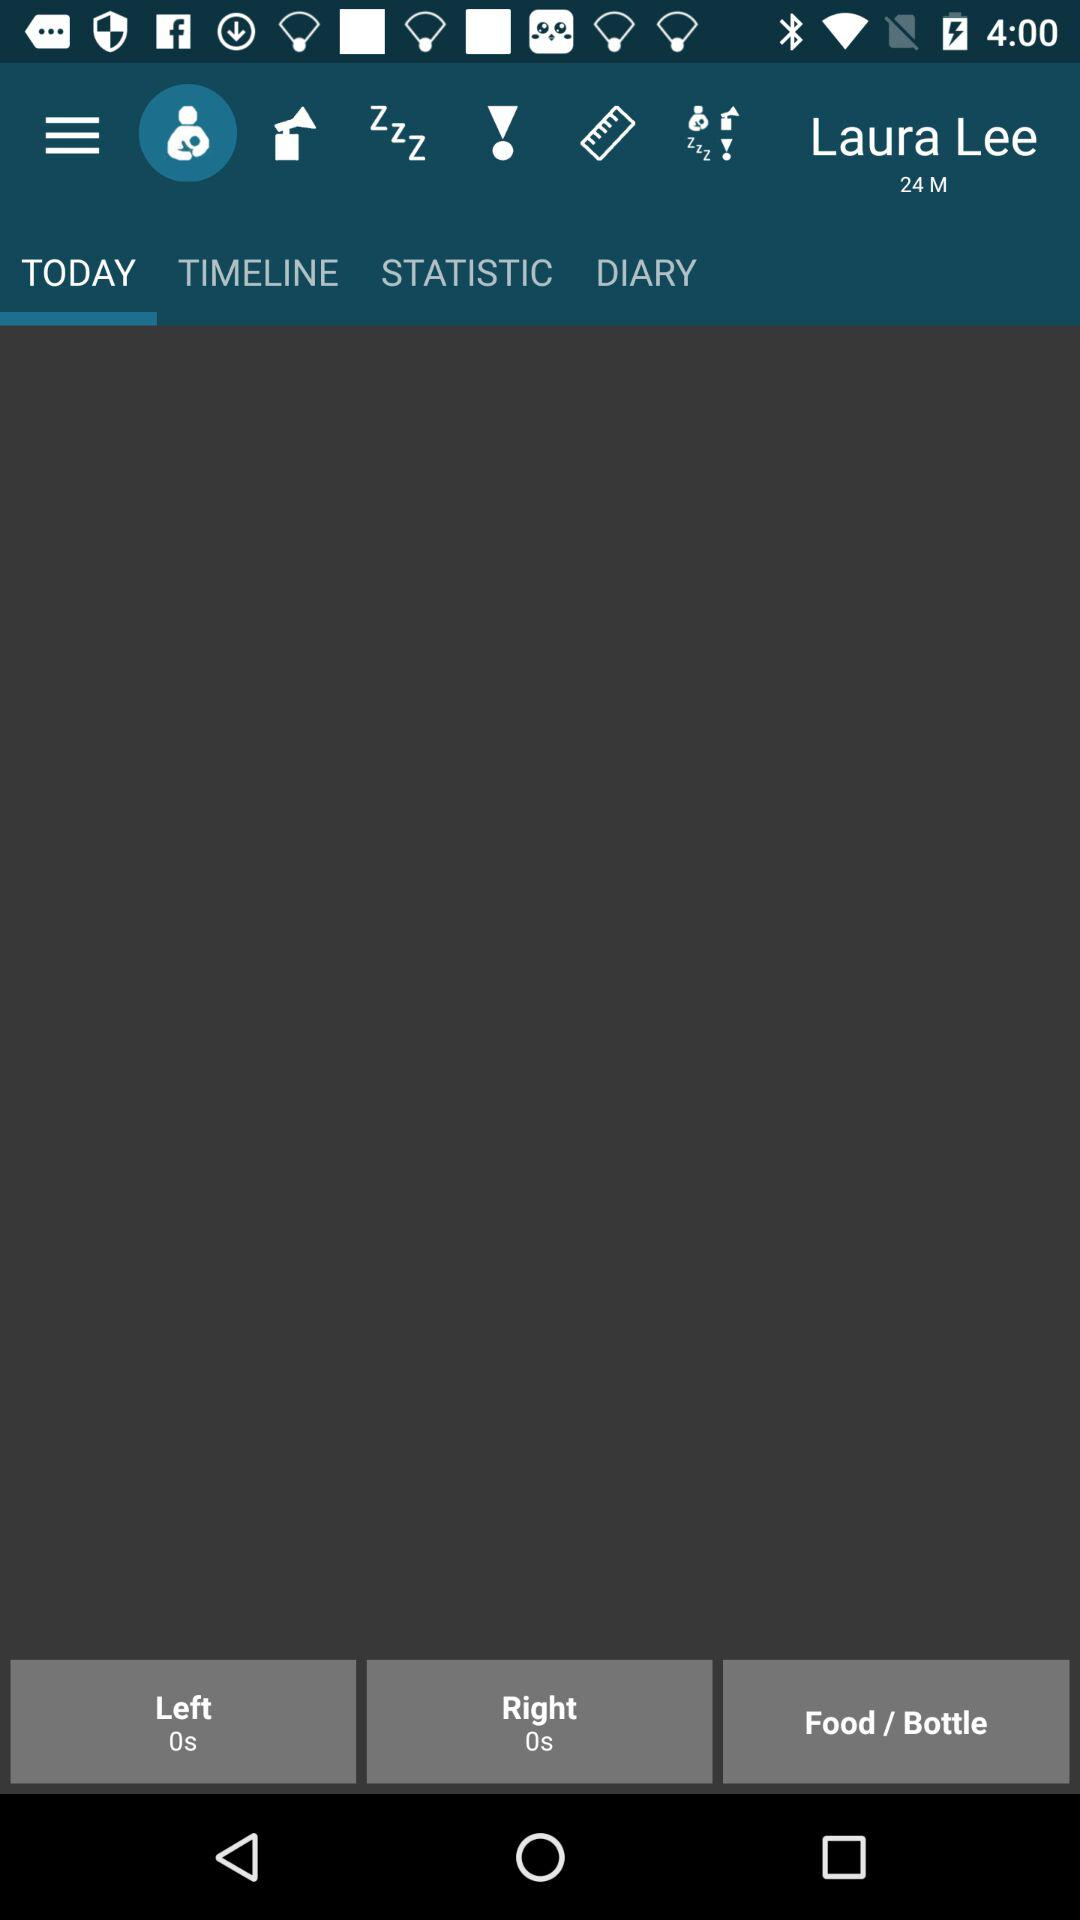What is the age? The age is 24 years. 